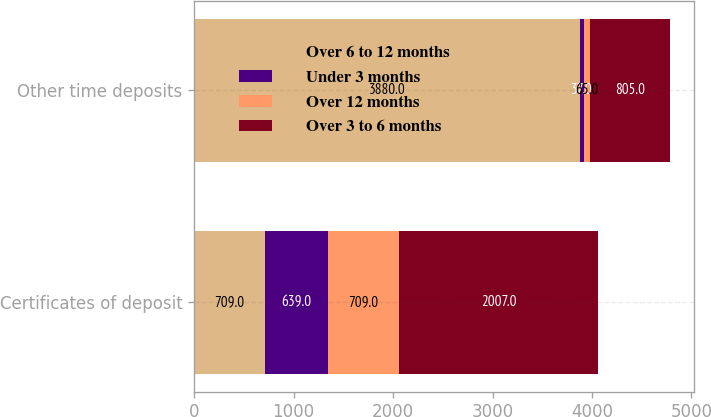Convert chart to OTSL. <chart><loc_0><loc_0><loc_500><loc_500><stacked_bar_chart><ecel><fcel>Certificates of deposit<fcel>Other time deposits<nl><fcel>Over 6 to 12 months<fcel>709<fcel>3880<nl><fcel>Under 3 months<fcel>639<fcel>37<nl><fcel>Over 12 months<fcel>709<fcel>65<nl><fcel>Over 3 to 6 months<fcel>2007<fcel>805<nl></chart> 